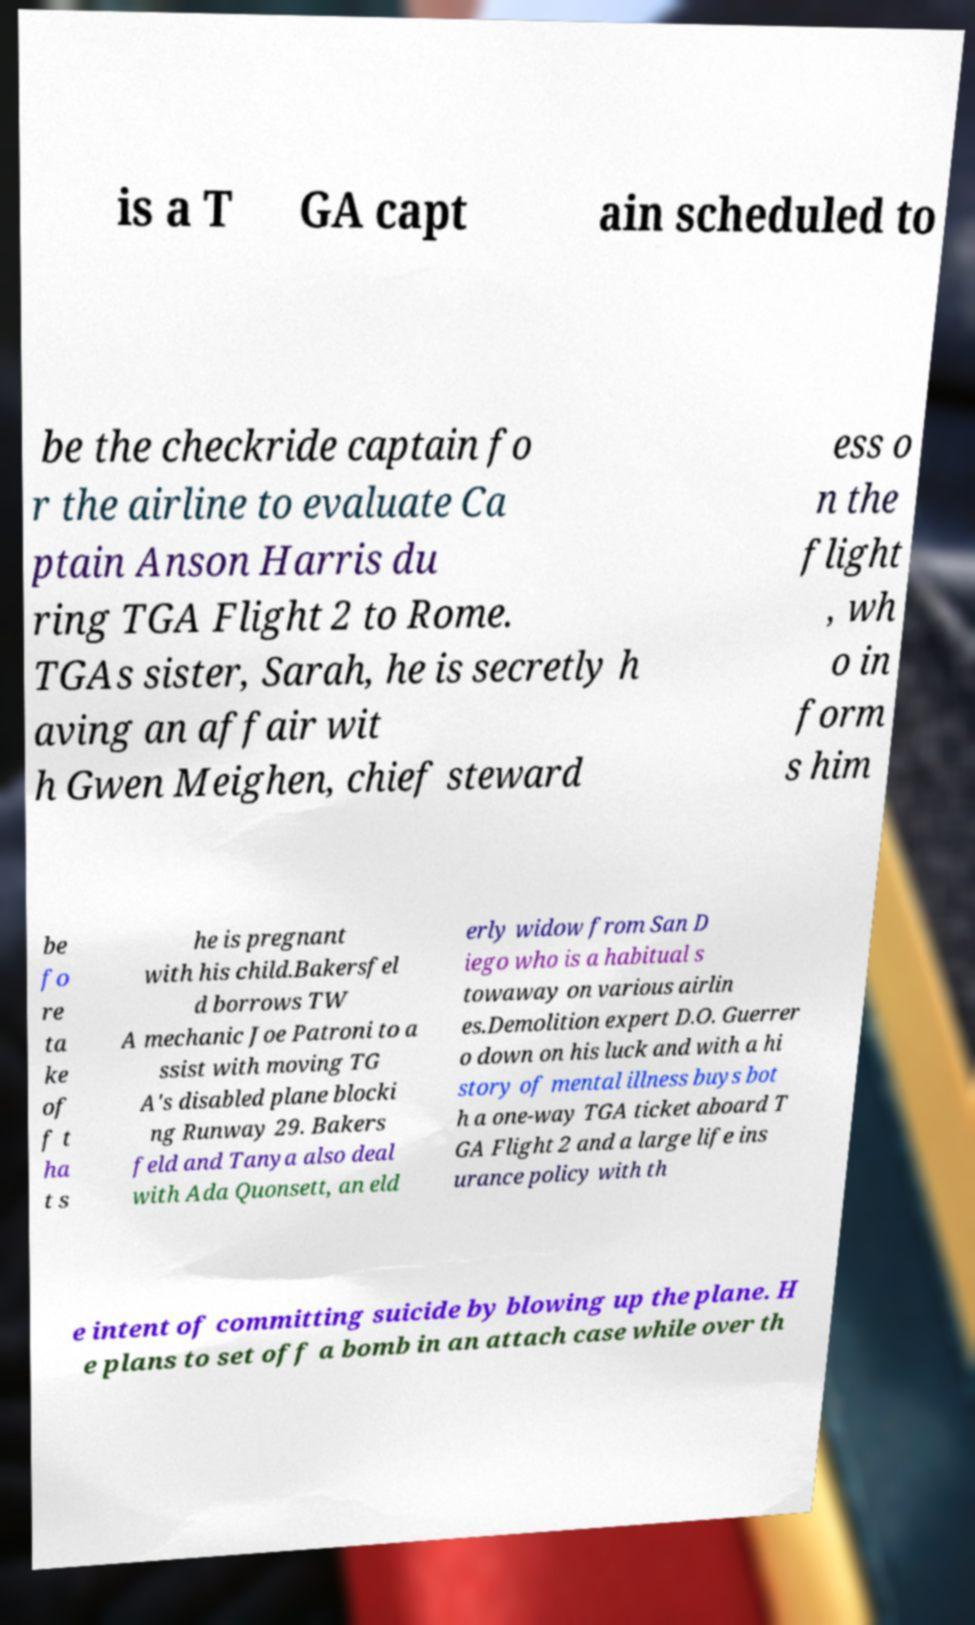Could you assist in decoding the text presented in this image and type it out clearly? is a T GA capt ain scheduled to be the checkride captain fo r the airline to evaluate Ca ptain Anson Harris du ring TGA Flight 2 to Rome. TGAs sister, Sarah, he is secretly h aving an affair wit h Gwen Meighen, chief steward ess o n the flight , wh o in form s him be fo re ta ke of f t ha t s he is pregnant with his child.Bakersfel d borrows TW A mechanic Joe Patroni to a ssist with moving TG A's disabled plane blocki ng Runway 29. Bakers feld and Tanya also deal with Ada Quonsett, an eld erly widow from San D iego who is a habitual s towaway on various airlin es.Demolition expert D.O. Guerrer o down on his luck and with a hi story of mental illness buys bot h a one-way TGA ticket aboard T GA Flight 2 and a large life ins urance policy with th e intent of committing suicide by blowing up the plane. H e plans to set off a bomb in an attach case while over th 